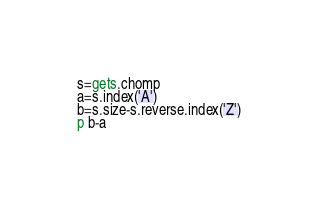Convert code to text. <code><loc_0><loc_0><loc_500><loc_500><_Ruby_>s=gets.chomp
a=s.index('A')
b=s.size-s.reverse.index('Z')
p b-a</code> 